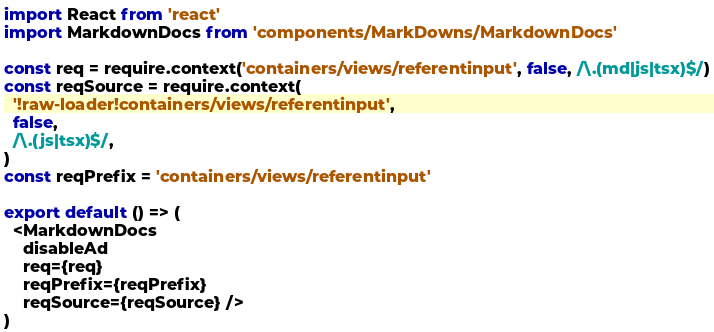<code> <loc_0><loc_0><loc_500><loc_500><_JavaScript_>import React from 'react'
import MarkdownDocs from 'components/MarkDowns/MarkdownDocs'

const req = require.context('containers/views/referentinput', false, /\.(md|js|tsx)$/)
const reqSource = require.context(
  '!raw-loader!containers/views/referentinput',
  false,
  /\.(js|tsx)$/,
)
const reqPrefix = 'containers/views/referentinput'

export default () => (
  <MarkdownDocs
    disableAd
    req={req}
    reqPrefix={reqPrefix}
    reqSource={reqSource} />
)
</code> 